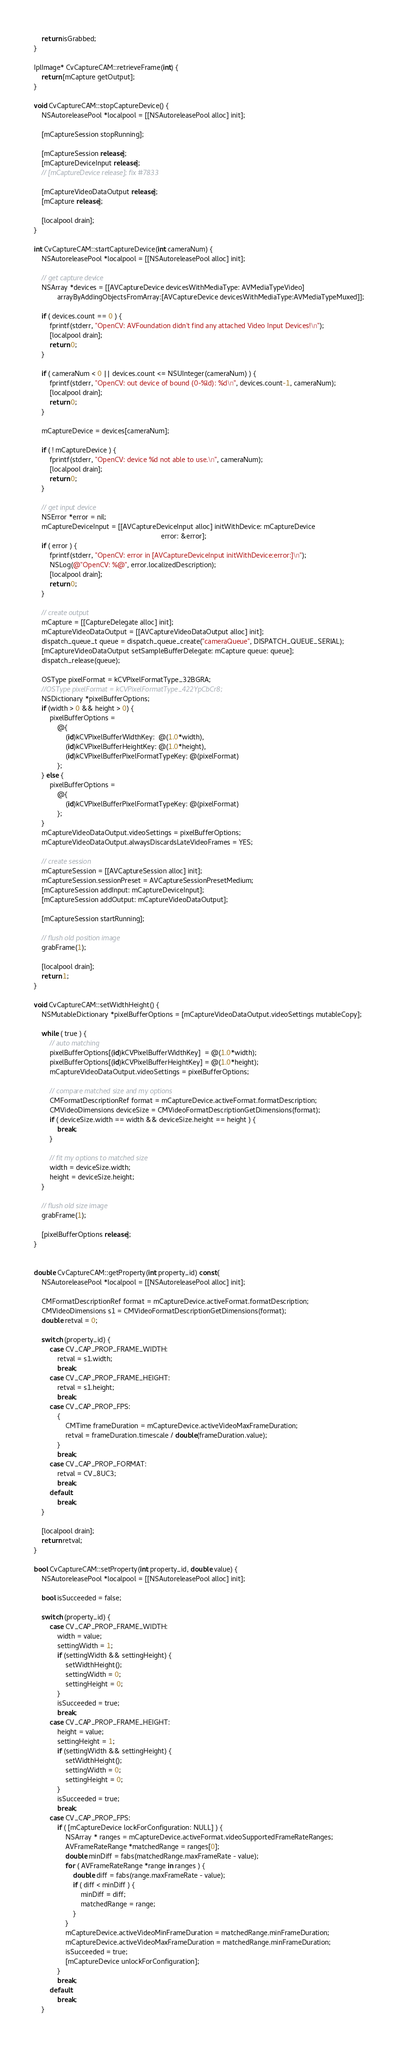Convert code to text. <code><loc_0><loc_0><loc_500><loc_500><_ObjectiveC_>    return isGrabbed;
}

IplImage* CvCaptureCAM::retrieveFrame(int) {
    return [mCapture getOutput];
}

void CvCaptureCAM::stopCaptureDevice() {
    NSAutoreleasePool *localpool = [[NSAutoreleasePool alloc] init];

    [mCaptureSession stopRunning];

    [mCaptureSession release];
    [mCaptureDeviceInput release];
    // [mCaptureDevice release]; fix #7833

    [mCaptureVideoDataOutput release];
    [mCapture release];

    [localpool drain];
}

int CvCaptureCAM::startCaptureDevice(int cameraNum) {
    NSAutoreleasePool *localpool = [[NSAutoreleasePool alloc] init];

    // get capture device
    NSArray *devices = [[AVCaptureDevice devicesWithMediaType: AVMediaTypeVideo]
            arrayByAddingObjectsFromArray:[AVCaptureDevice devicesWithMediaType:AVMediaTypeMuxed]];

    if ( devices.count == 0 ) {
        fprintf(stderr, "OpenCV: AVFoundation didn't find any attached Video Input Devices!\n");
        [localpool drain];
        return 0;
    }

    if ( cameraNum < 0 || devices.count <= NSUInteger(cameraNum) ) {
        fprintf(stderr, "OpenCV: out device of bound (0-%ld): %d\n", devices.count-1, cameraNum);
        [localpool drain];
        return 0;
    }

    mCaptureDevice = devices[cameraNum];

    if ( ! mCaptureDevice ) {
        fprintf(stderr, "OpenCV: device %d not able to use.\n", cameraNum);
        [localpool drain];
        return 0;
    }

    // get input device
    NSError *error = nil;
    mCaptureDeviceInput = [[AVCaptureDeviceInput alloc] initWithDevice: mCaptureDevice
                                                                 error: &error];
    if ( error ) {
        fprintf(stderr, "OpenCV: error in [AVCaptureDeviceInput initWithDevice:error:]\n");
        NSLog(@"OpenCV: %@", error.localizedDescription);
        [localpool drain];
        return 0;
    }

    // create output
    mCapture = [[CaptureDelegate alloc] init];
    mCaptureVideoDataOutput = [[AVCaptureVideoDataOutput alloc] init];
    dispatch_queue_t queue = dispatch_queue_create("cameraQueue", DISPATCH_QUEUE_SERIAL);
    [mCaptureVideoDataOutput setSampleBufferDelegate: mCapture queue: queue];
    dispatch_release(queue);

    OSType pixelFormat = kCVPixelFormatType_32BGRA;
    //OSType pixelFormat = kCVPixelFormatType_422YpCbCr8;
    NSDictionary *pixelBufferOptions;
    if (width > 0 && height > 0) {
        pixelBufferOptions =
            @{
                (id)kCVPixelBufferWidthKey:  @(1.0*width),
                (id)kCVPixelBufferHeightKey: @(1.0*height),
                (id)kCVPixelBufferPixelFormatTypeKey: @(pixelFormat)
            };
    } else {
        pixelBufferOptions =
            @{
                (id)kCVPixelBufferPixelFormatTypeKey: @(pixelFormat)
            };
    }
    mCaptureVideoDataOutput.videoSettings = pixelBufferOptions;
    mCaptureVideoDataOutput.alwaysDiscardsLateVideoFrames = YES;

    // create session
    mCaptureSession = [[AVCaptureSession alloc] init];
    mCaptureSession.sessionPreset = AVCaptureSessionPresetMedium;
    [mCaptureSession addInput: mCaptureDeviceInput];
    [mCaptureSession addOutput: mCaptureVideoDataOutput];

    [mCaptureSession startRunning];

    // flush old position image
    grabFrame(1);

    [localpool drain];
    return 1;
}

void CvCaptureCAM::setWidthHeight() {
    NSMutableDictionary *pixelBufferOptions = [mCaptureVideoDataOutput.videoSettings mutableCopy];

    while ( true ) {
        // auto matching
        pixelBufferOptions[(id)kCVPixelBufferWidthKey]  = @(1.0*width);
        pixelBufferOptions[(id)kCVPixelBufferHeightKey] = @(1.0*height);
        mCaptureVideoDataOutput.videoSettings = pixelBufferOptions;

        // compare matched size and my options
        CMFormatDescriptionRef format = mCaptureDevice.activeFormat.formatDescription;
        CMVideoDimensions deviceSize = CMVideoFormatDescriptionGetDimensions(format);
        if ( deviceSize.width == width && deviceSize.height == height ) {
            break;
        }

        // fit my options to matched size
        width = deviceSize.width;
        height = deviceSize.height;
    }

    // flush old size image
    grabFrame(1);

    [pixelBufferOptions release];
}


double CvCaptureCAM::getProperty(int property_id) const{
    NSAutoreleasePool *localpool = [[NSAutoreleasePool alloc] init];

    CMFormatDescriptionRef format = mCaptureDevice.activeFormat.formatDescription;
    CMVideoDimensions s1 = CMVideoFormatDescriptionGetDimensions(format);
    double retval = 0;

    switch (property_id) {
        case CV_CAP_PROP_FRAME_WIDTH:
            retval = s1.width;
            break;
        case CV_CAP_PROP_FRAME_HEIGHT:
            retval = s1.height;
            break;
        case CV_CAP_PROP_FPS:
            {
                CMTime frameDuration = mCaptureDevice.activeVideoMaxFrameDuration;
                retval = frameDuration.timescale / double(frameDuration.value);
            }
            break;
        case CV_CAP_PROP_FORMAT:
            retval = CV_8UC3;
            break;
        default:
            break;
    }

    [localpool drain];
    return retval;
}

bool CvCaptureCAM::setProperty(int property_id, double value) {
    NSAutoreleasePool *localpool = [[NSAutoreleasePool alloc] init];

    bool isSucceeded = false;

    switch (property_id) {
        case CV_CAP_PROP_FRAME_WIDTH:
            width = value;
            settingWidth = 1;
            if (settingWidth && settingHeight) {
                setWidthHeight();
                settingWidth = 0;
                settingHeight = 0;
            }
            isSucceeded = true;
            break;
        case CV_CAP_PROP_FRAME_HEIGHT:
            height = value;
            settingHeight = 1;
            if (settingWidth && settingHeight) {
                setWidthHeight();
                settingWidth = 0;
                settingHeight = 0;
            }
            isSucceeded = true;
            break;
        case CV_CAP_PROP_FPS:
            if ( [mCaptureDevice lockForConfiguration: NULL] ) {
                NSArray * ranges = mCaptureDevice.activeFormat.videoSupportedFrameRateRanges;
                AVFrameRateRange *matchedRange = ranges[0];
                double minDiff = fabs(matchedRange.maxFrameRate - value);
                for ( AVFrameRateRange *range in ranges ) {
                    double diff = fabs(range.maxFrameRate - value);
                    if ( diff < minDiff ) {
                        minDiff = diff;
                        matchedRange = range;
                    }
                }
                mCaptureDevice.activeVideoMinFrameDuration = matchedRange.minFrameDuration;
                mCaptureDevice.activeVideoMaxFrameDuration = matchedRange.minFrameDuration;
                isSucceeded = true;
                [mCaptureDevice unlockForConfiguration];
            }
            break;
        default:
            break;
    }
</code> 